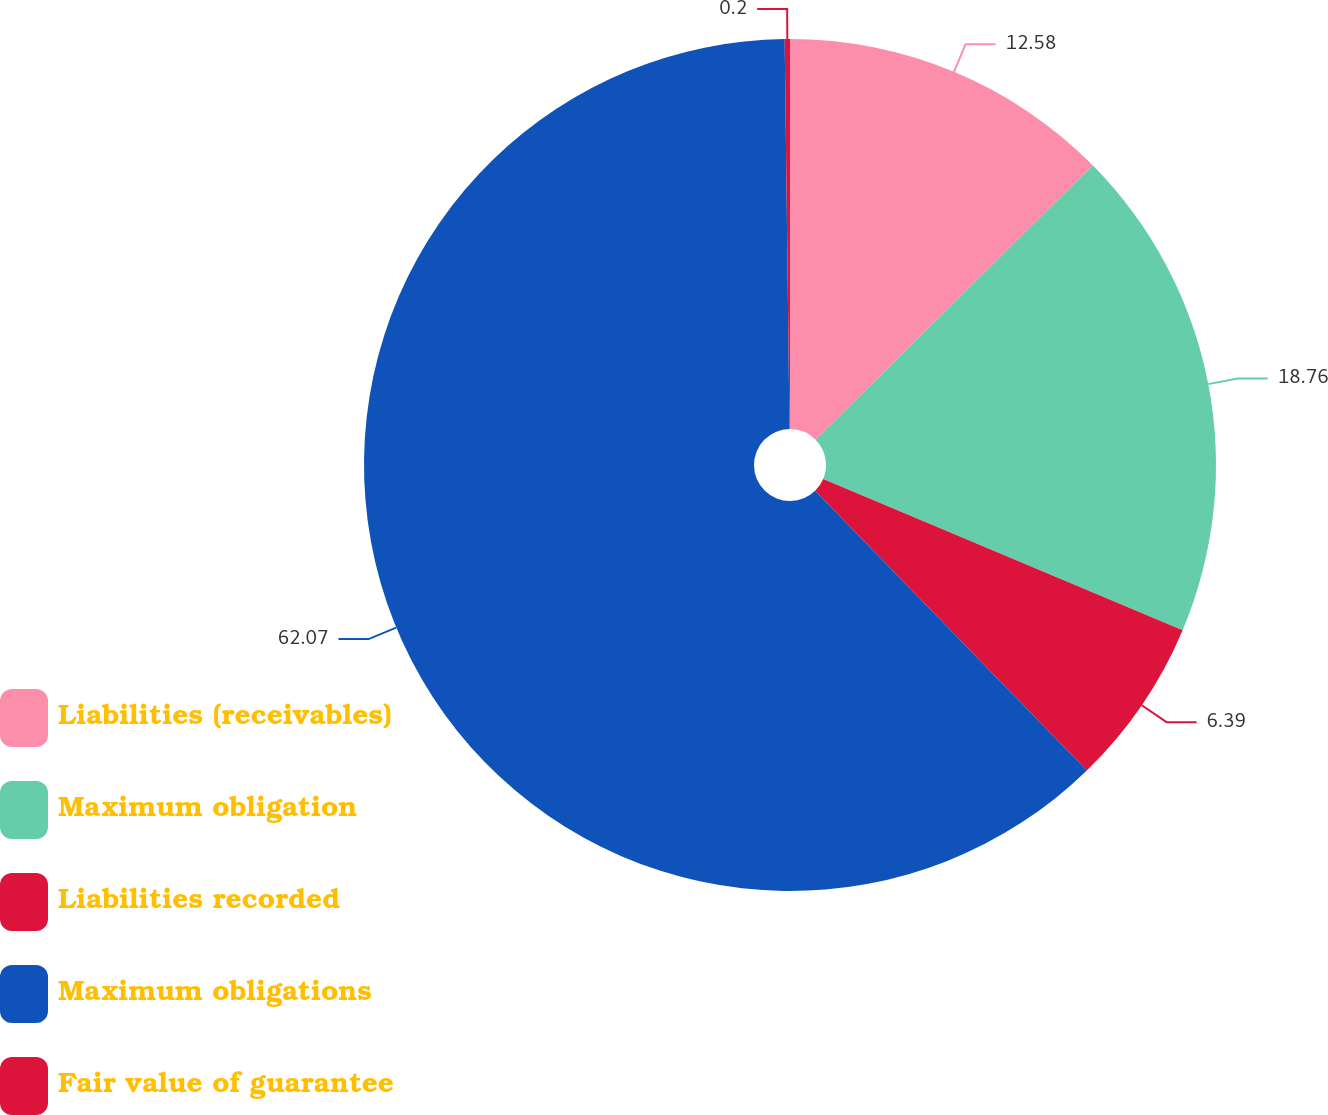Convert chart to OTSL. <chart><loc_0><loc_0><loc_500><loc_500><pie_chart><fcel>Liabilities (receivables)<fcel>Maximum obligation<fcel>Liabilities recorded<fcel>Maximum obligations<fcel>Fair value of guarantee<nl><fcel>12.58%<fcel>18.76%<fcel>6.39%<fcel>62.07%<fcel>0.2%<nl></chart> 